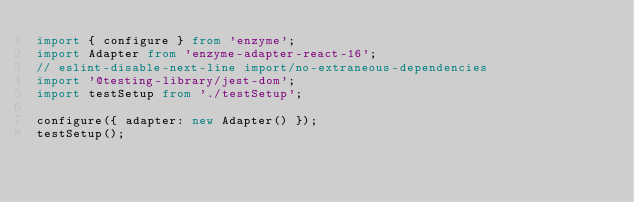<code> <loc_0><loc_0><loc_500><loc_500><_TypeScript_>import { configure } from 'enzyme';
import Adapter from 'enzyme-adapter-react-16';
// eslint-disable-next-line import/no-extraneous-dependencies
import '@testing-library/jest-dom';
import testSetup from './testSetup';

configure({ adapter: new Adapter() });
testSetup();
</code> 